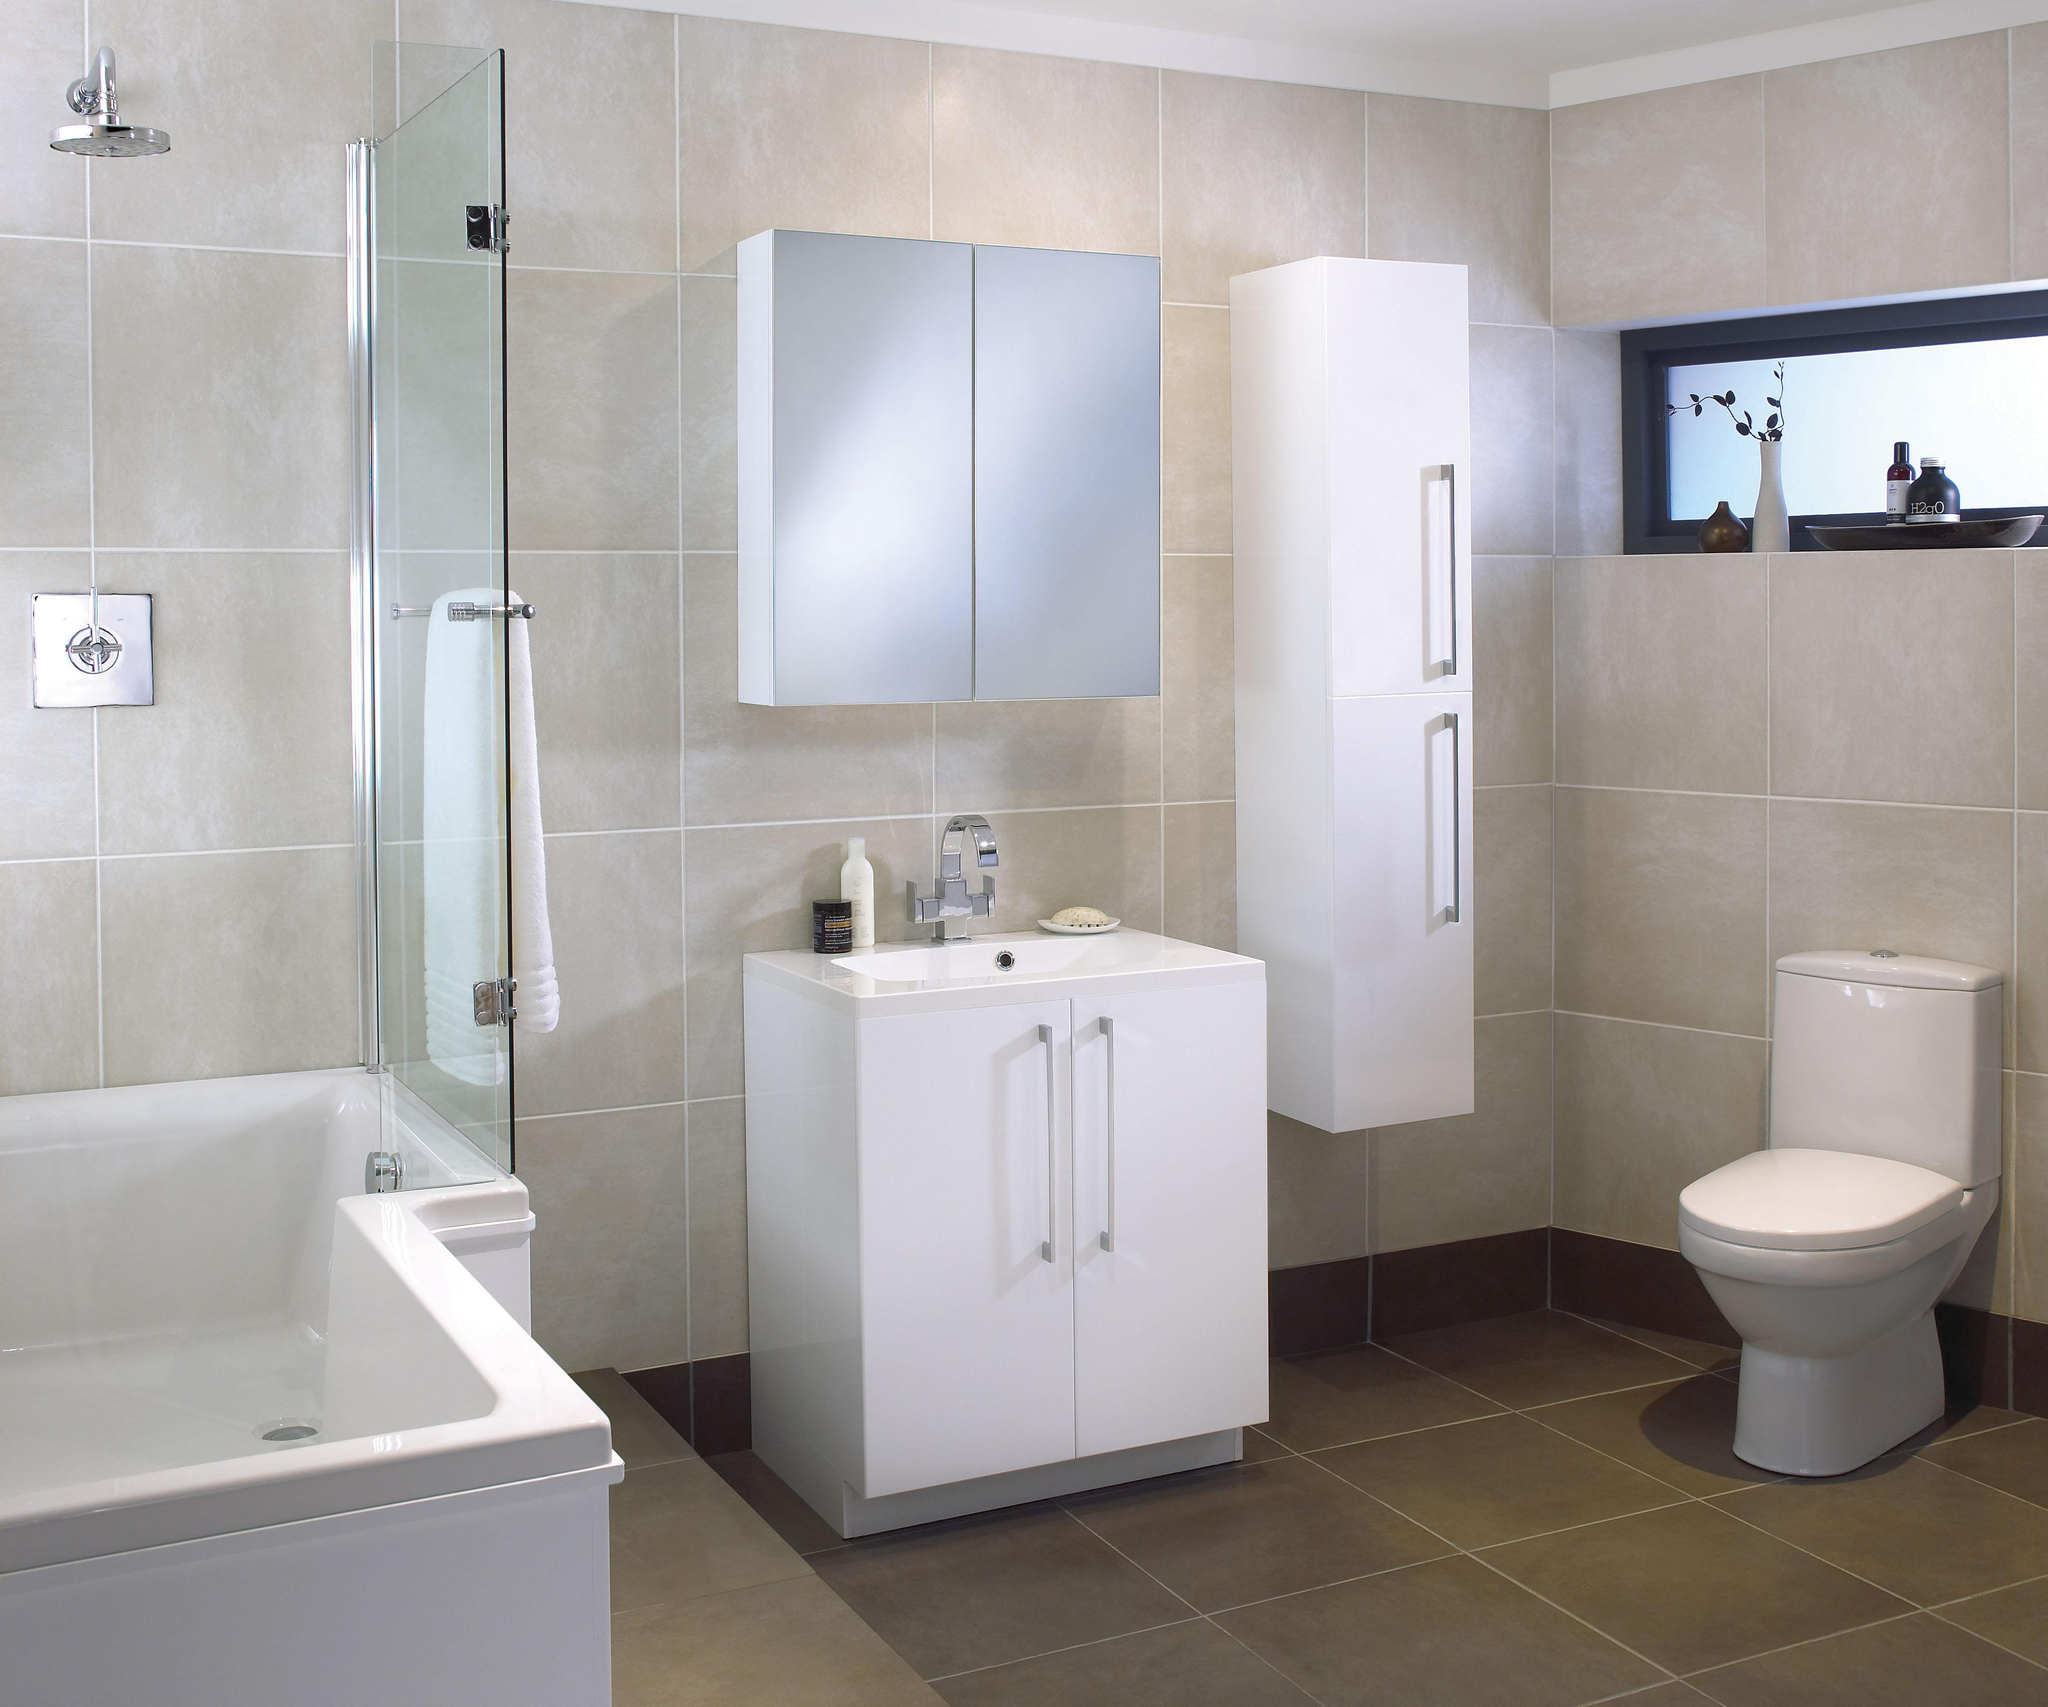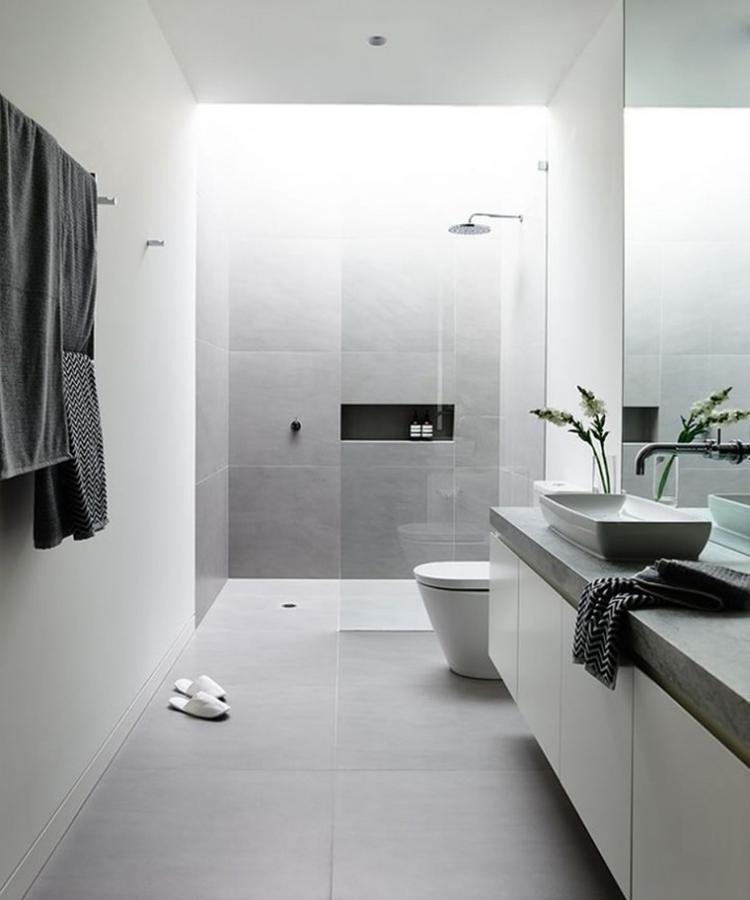The first image is the image on the left, the second image is the image on the right. Given the left and right images, does the statement "One of the toilets is connected to a wood cabinet." hold true? Answer yes or no. No. The first image is the image on the left, the second image is the image on the right. Evaluate the accuracy of this statement regarding the images: "A white commode is attached at one end of a white vanity, with a white sink attached at the other end over double doors.". Is it true? Answer yes or no. No. 